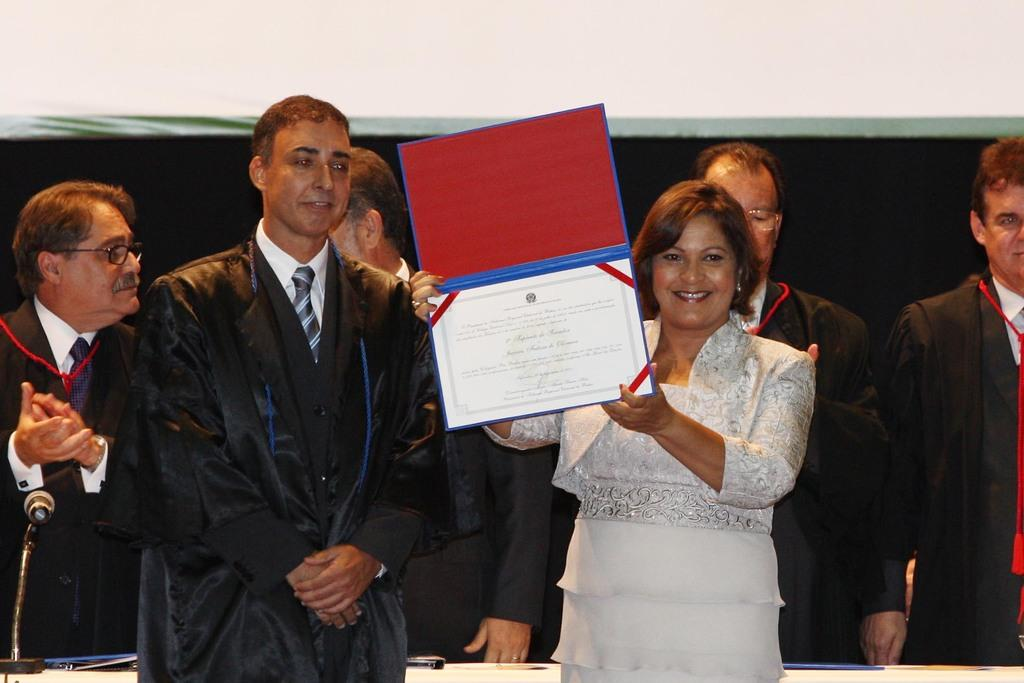Who is the main subject in the image? There is a woman in the image. What is the woman holding in the image? The woman is holding a certificate. Are there any other people in the image besides the woman? Yes, there are men in the image. What are the men wearing in the image? The men are wearing suits. What type of seed can be seen growing in the image? There is no seed or plant visible in the image. How many socks are visible on the men's feet in the image? The image does not show the men's feet, so it is not possible to determine if they are wearing socks. 